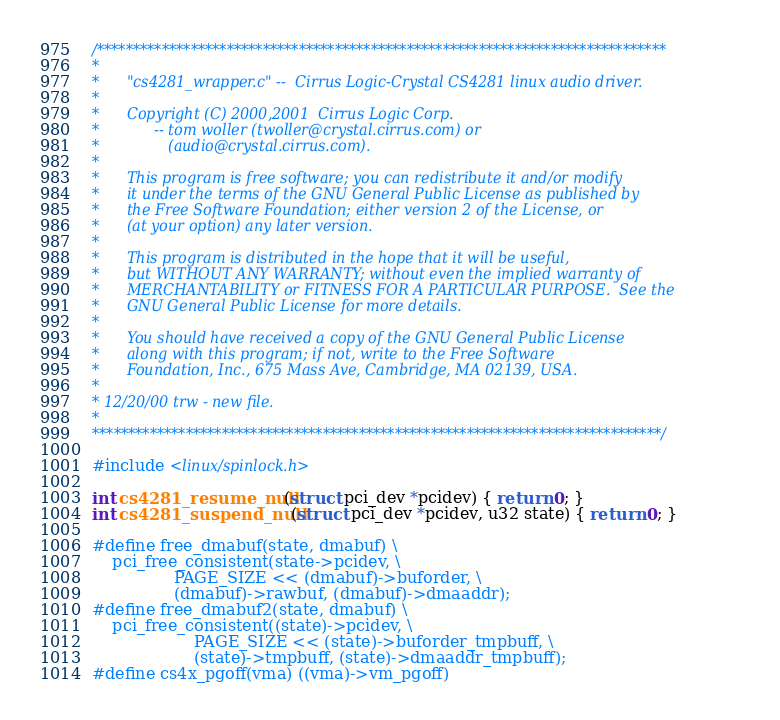<code> <loc_0><loc_0><loc_500><loc_500><_C_>/*******************************************************************************
*
*      "cs4281_wrapper.c" --  Cirrus Logic-Crystal CS4281 linux audio driver.
*
*      Copyright (C) 2000,2001  Cirrus Logic Corp.  
*            -- tom woller (twoller@crystal.cirrus.com) or
*               (audio@crystal.cirrus.com).
*
*      This program is free software; you can redistribute it and/or modify
*      it under the terms of the GNU General Public License as published by
*      the Free Software Foundation; either version 2 of the License, or
*      (at your option) any later version.
*
*      This program is distributed in the hope that it will be useful,
*      but WITHOUT ANY WARRANTY; without even the implied warranty of
*      MERCHANTABILITY or FITNESS FOR A PARTICULAR PURPOSE.  See the
*      GNU General Public License for more details.
*
*      You should have received a copy of the GNU General Public License
*      along with this program; if not, write to the Free Software
*      Foundation, Inc., 675 Mass Ave, Cambridge, MA 02139, USA.
*
* 12/20/00 trw - new file. 
*
*******************************************************************************/

#include <linux/spinlock.h>

int cs4281_resume_null(struct pci_dev *pcidev) { return 0; }
int cs4281_suspend_null(struct pci_dev *pcidev, u32 state) { return 0; }

#define free_dmabuf(state, dmabuf) \
	pci_free_consistent(state->pcidev, \
			    PAGE_SIZE << (dmabuf)->buforder, \
			    (dmabuf)->rawbuf, (dmabuf)->dmaaddr);
#define free_dmabuf2(state, dmabuf) \
	pci_free_consistent((state)->pcidev, \
				    PAGE_SIZE << (state)->buforder_tmpbuff, \
				    (state)->tmpbuff, (state)->dmaaddr_tmpbuff);
#define cs4x_pgoff(vma) ((vma)->vm_pgoff)

</code> 